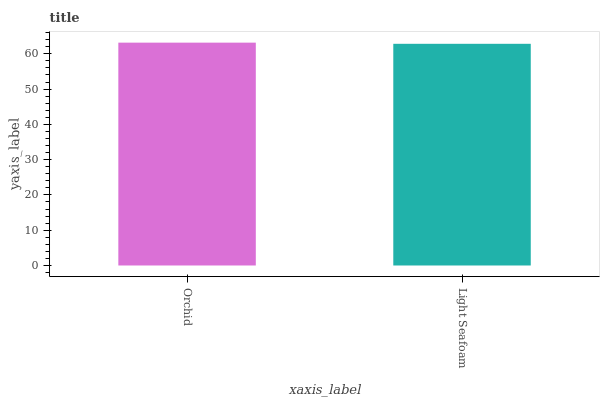Is Light Seafoam the maximum?
Answer yes or no. No. Is Orchid greater than Light Seafoam?
Answer yes or no. Yes. Is Light Seafoam less than Orchid?
Answer yes or no. Yes. Is Light Seafoam greater than Orchid?
Answer yes or no. No. Is Orchid less than Light Seafoam?
Answer yes or no. No. Is Orchid the high median?
Answer yes or no. Yes. Is Light Seafoam the low median?
Answer yes or no. Yes. Is Light Seafoam the high median?
Answer yes or no. No. Is Orchid the low median?
Answer yes or no. No. 